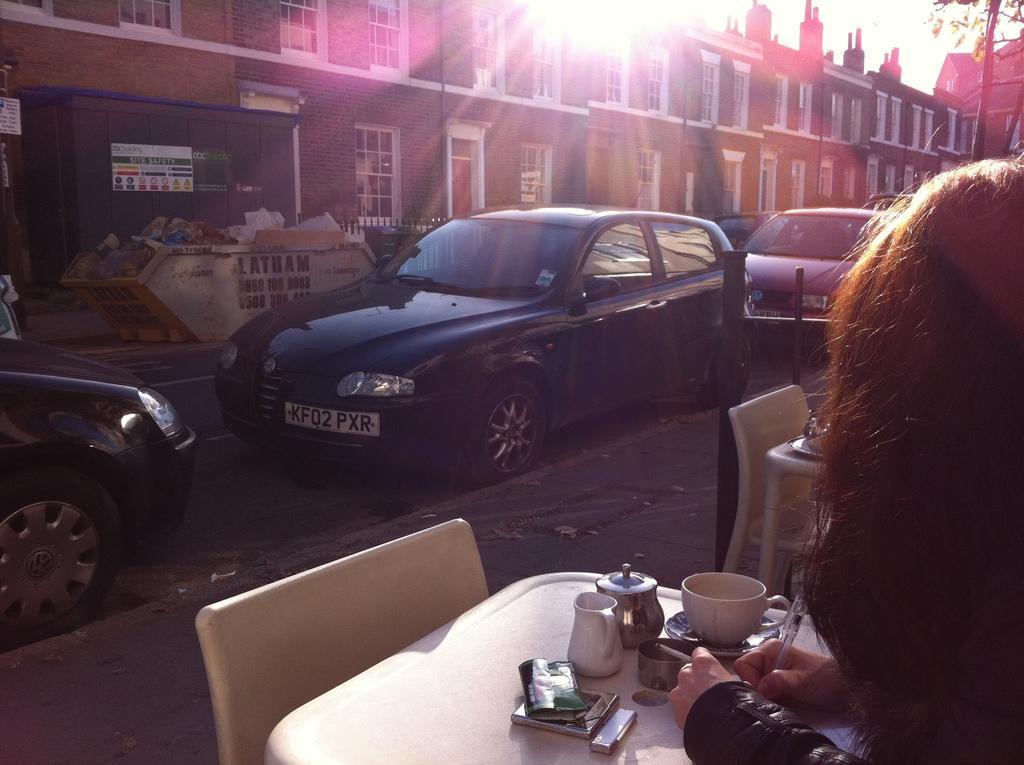In one or two sentences, can you explain what this image depicts? In this image i can see a person sitting and holding a pen. In the background i can see few vehicles, sky, a tree and a building. 